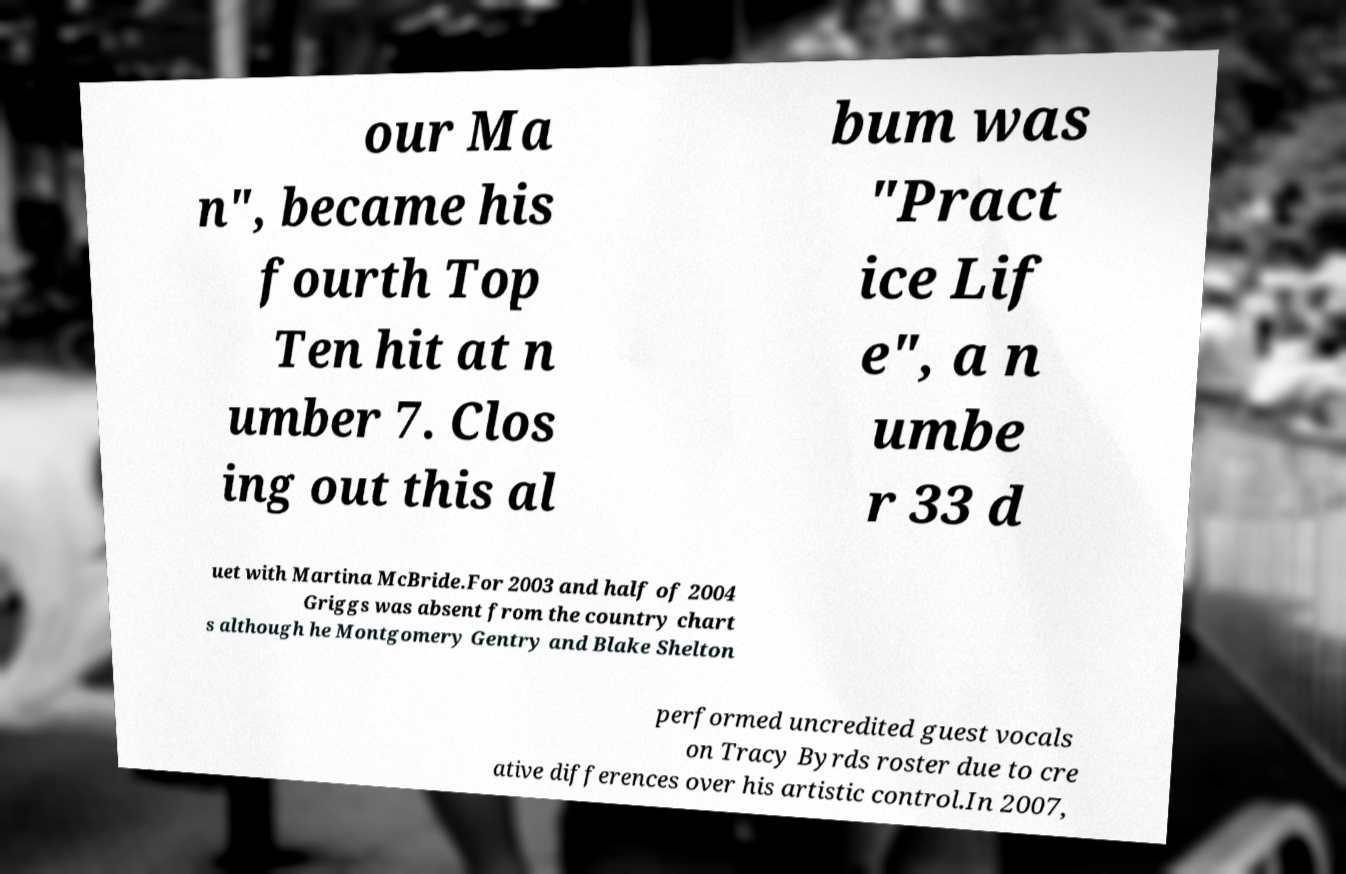There's text embedded in this image that I need extracted. Can you transcribe it verbatim? our Ma n", became his fourth Top Ten hit at n umber 7. Clos ing out this al bum was "Pract ice Lif e", a n umbe r 33 d uet with Martina McBride.For 2003 and half of 2004 Griggs was absent from the country chart s although he Montgomery Gentry and Blake Shelton performed uncredited guest vocals on Tracy Byrds roster due to cre ative differences over his artistic control.In 2007, 